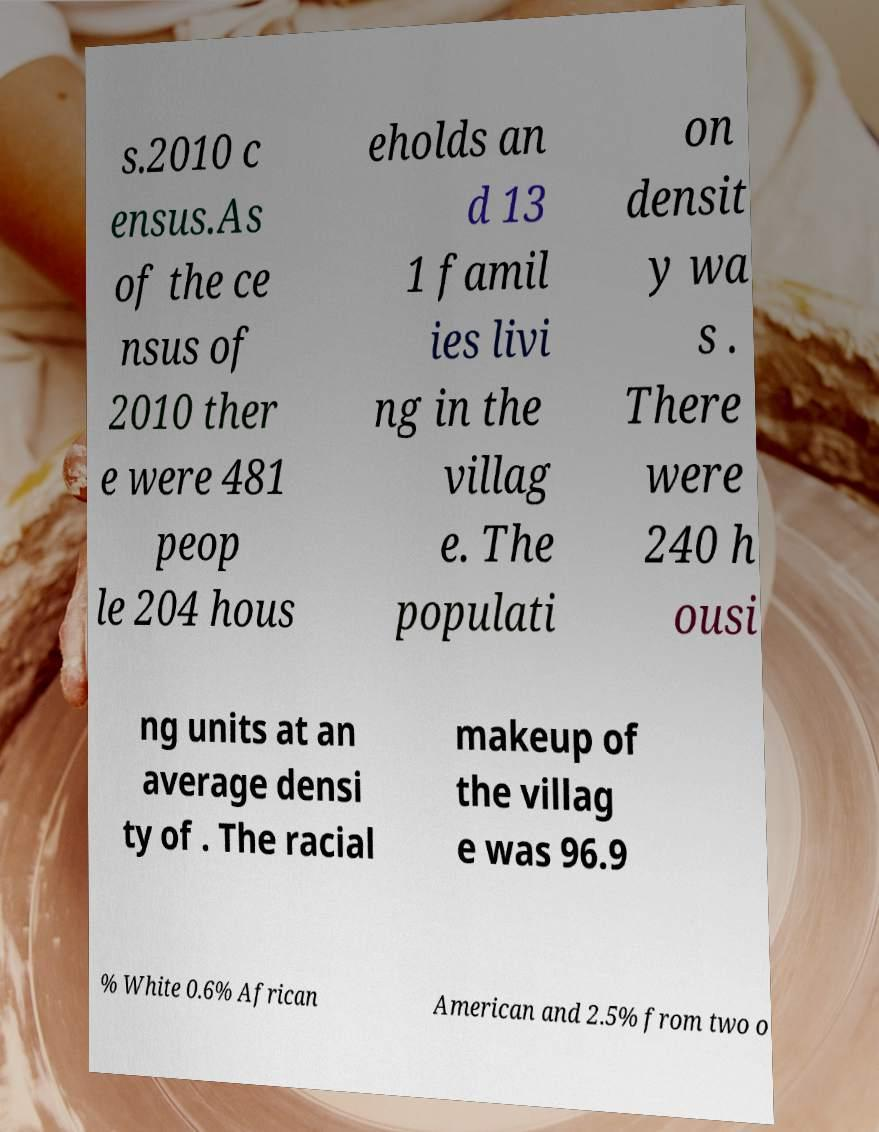There's text embedded in this image that I need extracted. Can you transcribe it verbatim? s.2010 c ensus.As of the ce nsus of 2010 ther e were 481 peop le 204 hous eholds an d 13 1 famil ies livi ng in the villag e. The populati on densit y wa s . There were 240 h ousi ng units at an average densi ty of . The racial makeup of the villag e was 96.9 % White 0.6% African American and 2.5% from two o 